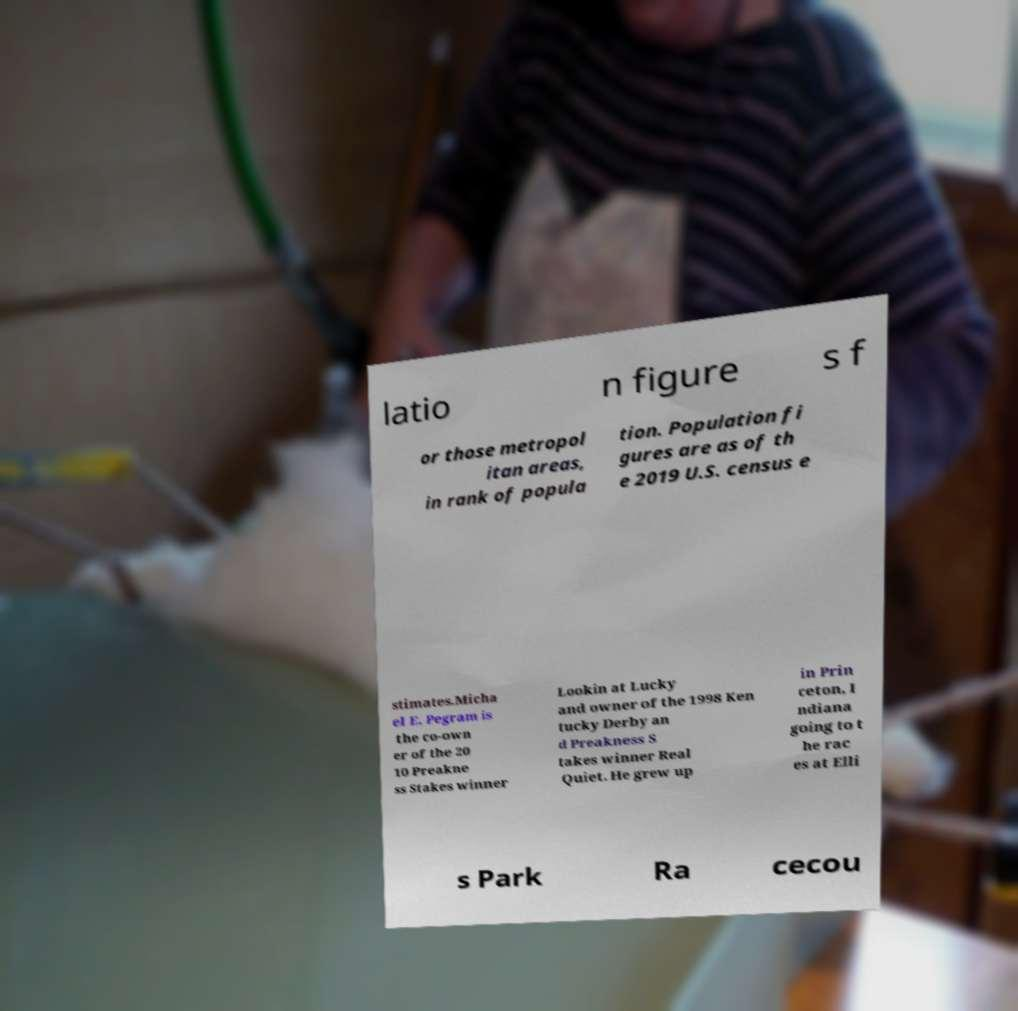Can you read and provide the text displayed in the image?This photo seems to have some interesting text. Can you extract and type it out for me? latio n figure s f or those metropol itan areas, in rank of popula tion. Population fi gures are as of th e 2019 U.S. census e stimates.Micha el E. Pegram is the co-own er of the 20 10 Preakne ss Stakes winner Lookin at Lucky and owner of the 1998 Ken tucky Derby an d Preakness S takes winner Real Quiet. He grew up in Prin ceton, I ndiana going to t he rac es at Elli s Park Ra cecou 